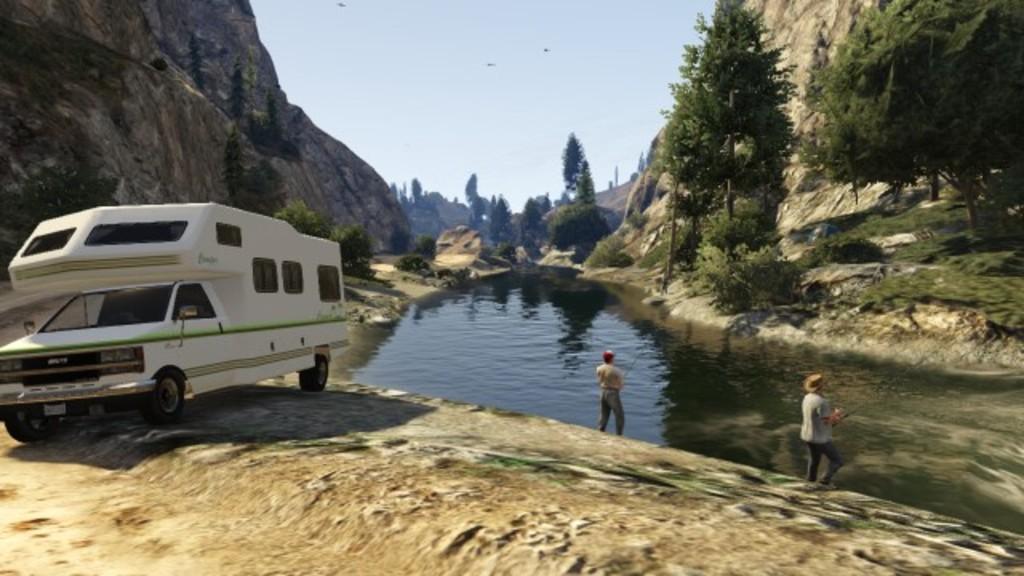Please provide a concise description of this image. In this picture we can see a vehicle on the ground, water, grass and two people are holding fishing rods with their hands. In the background we can see trees, mountains and the sky. 